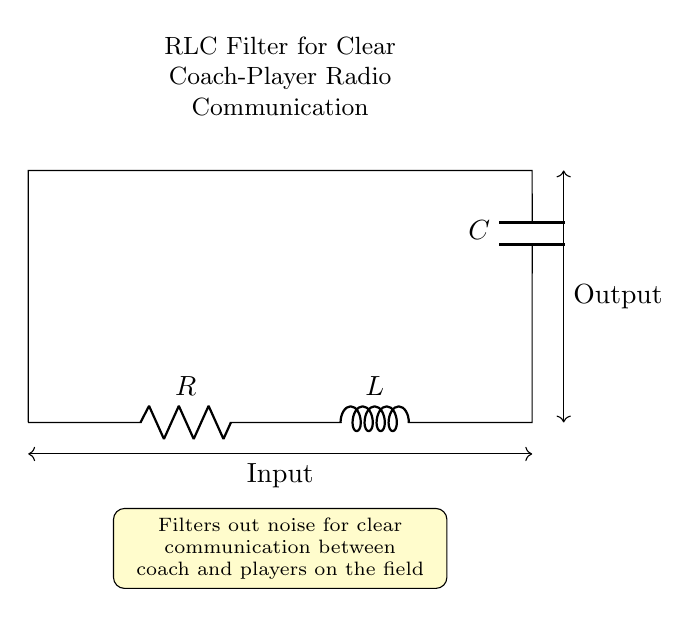What components are in the circuit? The circuit contains a resistor, an inductor, and a capacitor. These are the basic components shown in the diagram that form the RLC filter.
Answer: Resistor, inductor, capacitor What is the purpose of the RLC filter? The filter is designed to filter out noise for clear communication between the coach and players on the field, as stated in the description.
Answer: Filter out noise What is the type of this circuit? This is an RLC filter circuit, characterized specifically by the inclusion of a resistor, inductor, and capacitor arranged in a specific configuration.
Answer: RLC filter What is the input signal in the circuit? The input signal is indicated at the left side of the circuit diagram, where connections are made to the resistor for incoming signals.
Answer: Input How does the inductor affect the circuit's function? The inductor stores energy in a magnetic field when current passes through it, thus influencing the filter's frequency response and helping to filter signals.
Answer: It stores energy What happens at the output of the circuit? At the output, the circuit provides a filtered signal that should have less noise, enhancing the clarity of the communication between coach and players.
Answer: Provides filtered signal What is the configuration configuration of the components in this circuit? The components are arranged in series; the resistor, then the inductor, followed by the capacitor, which is connected to the input and output terminals.
Answer: Series configuration 